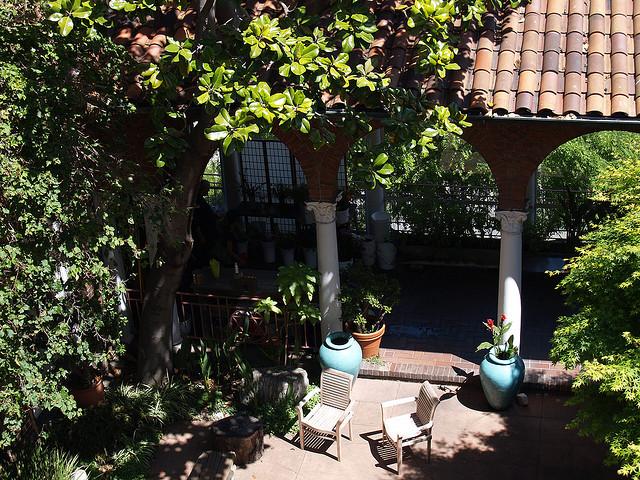What color are the pots on the patio?
Be succinct. Blue. What is the roof made of?
Be succinct. Tile. How many pots are on the patio?
Keep it brief. 3. 